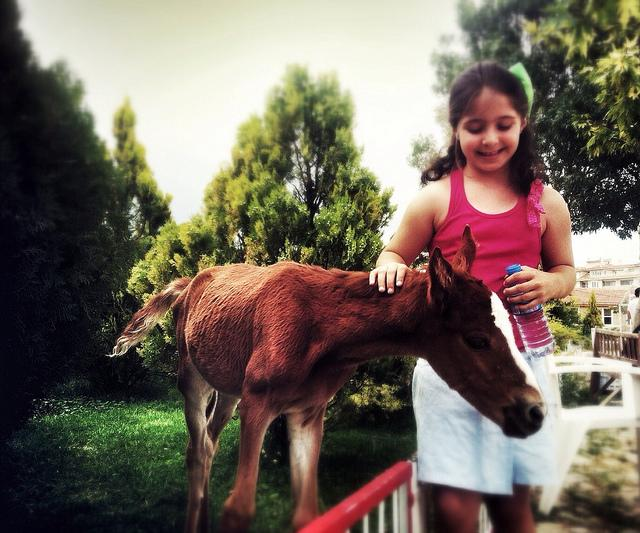What color is the cap on top of the water bottle held by the child? blue 